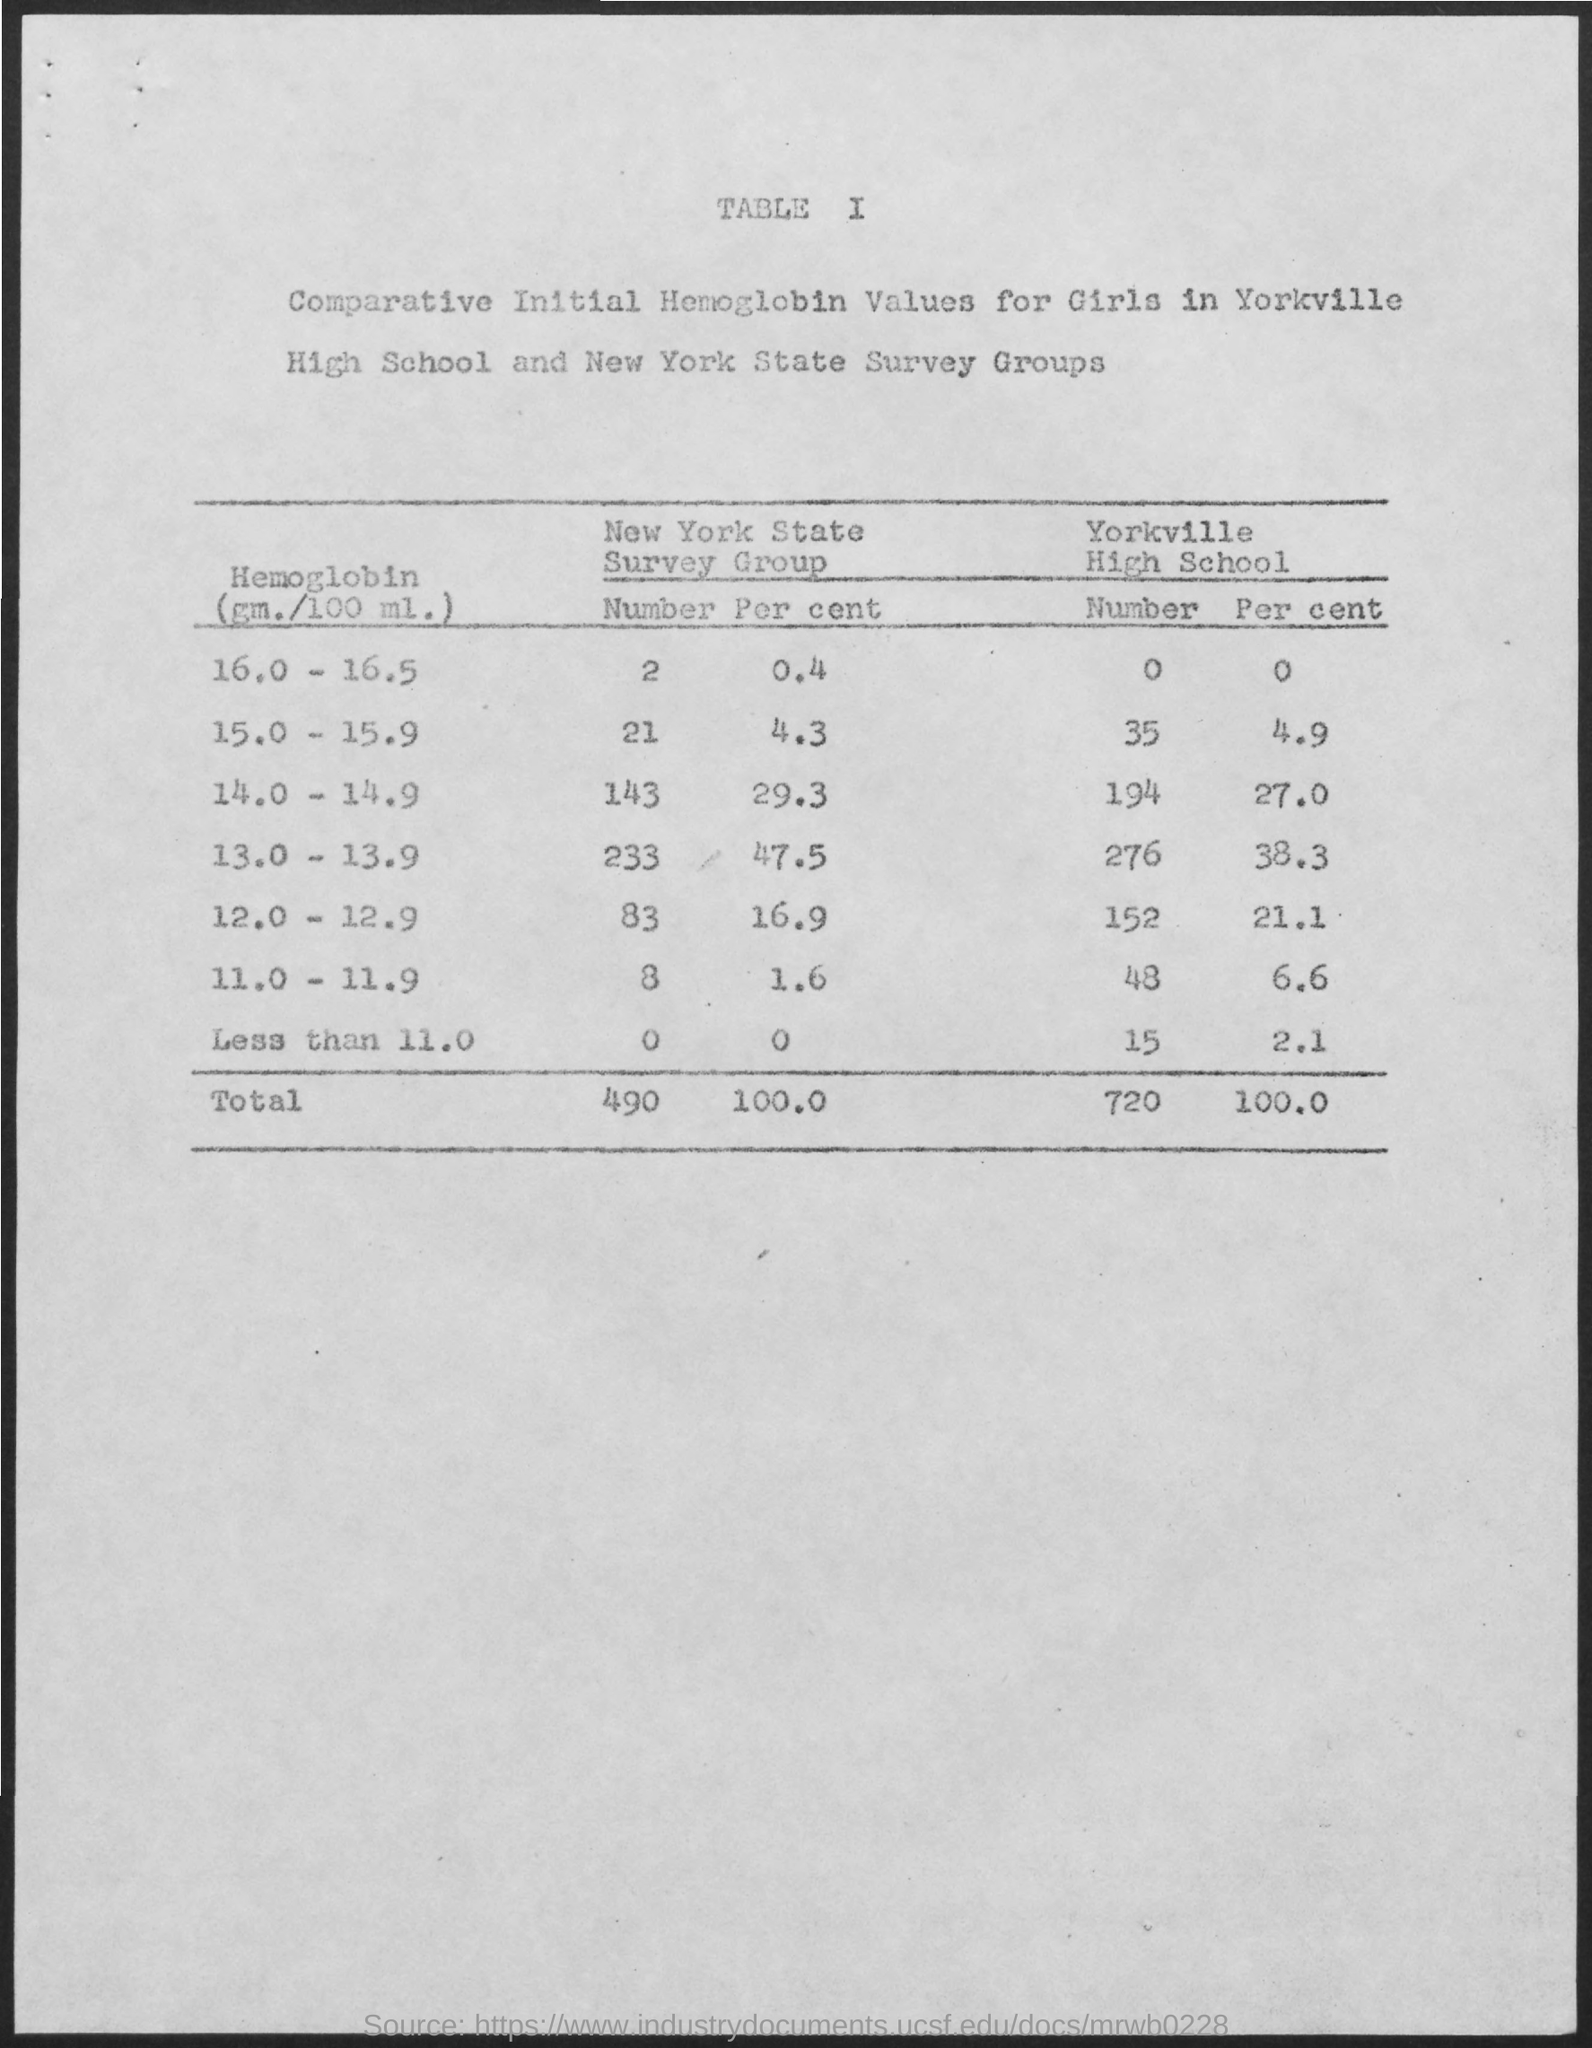What is the total number of New York State Survey Group?
Ensure brevity in your answer.  490. 